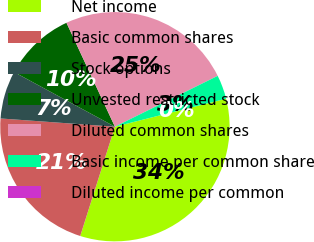Convert chart. <chart><loc_0><loc_0><loc_500><loc_500><pie_chart><fcel>Net income<fcel>Basic common shares<fcel>Stock options<fcel>Unvested restricted stock<fcel>Diluted common shares<fcel>Basic income per common share<fcel>Diluted income per common<nl><fcel>33.82%<fcel>21.25%<fcel>6.76%<fcel>10.15%<fcel>24.63%<fcel>3.38%<fcel>0.0%<nl></chart> 